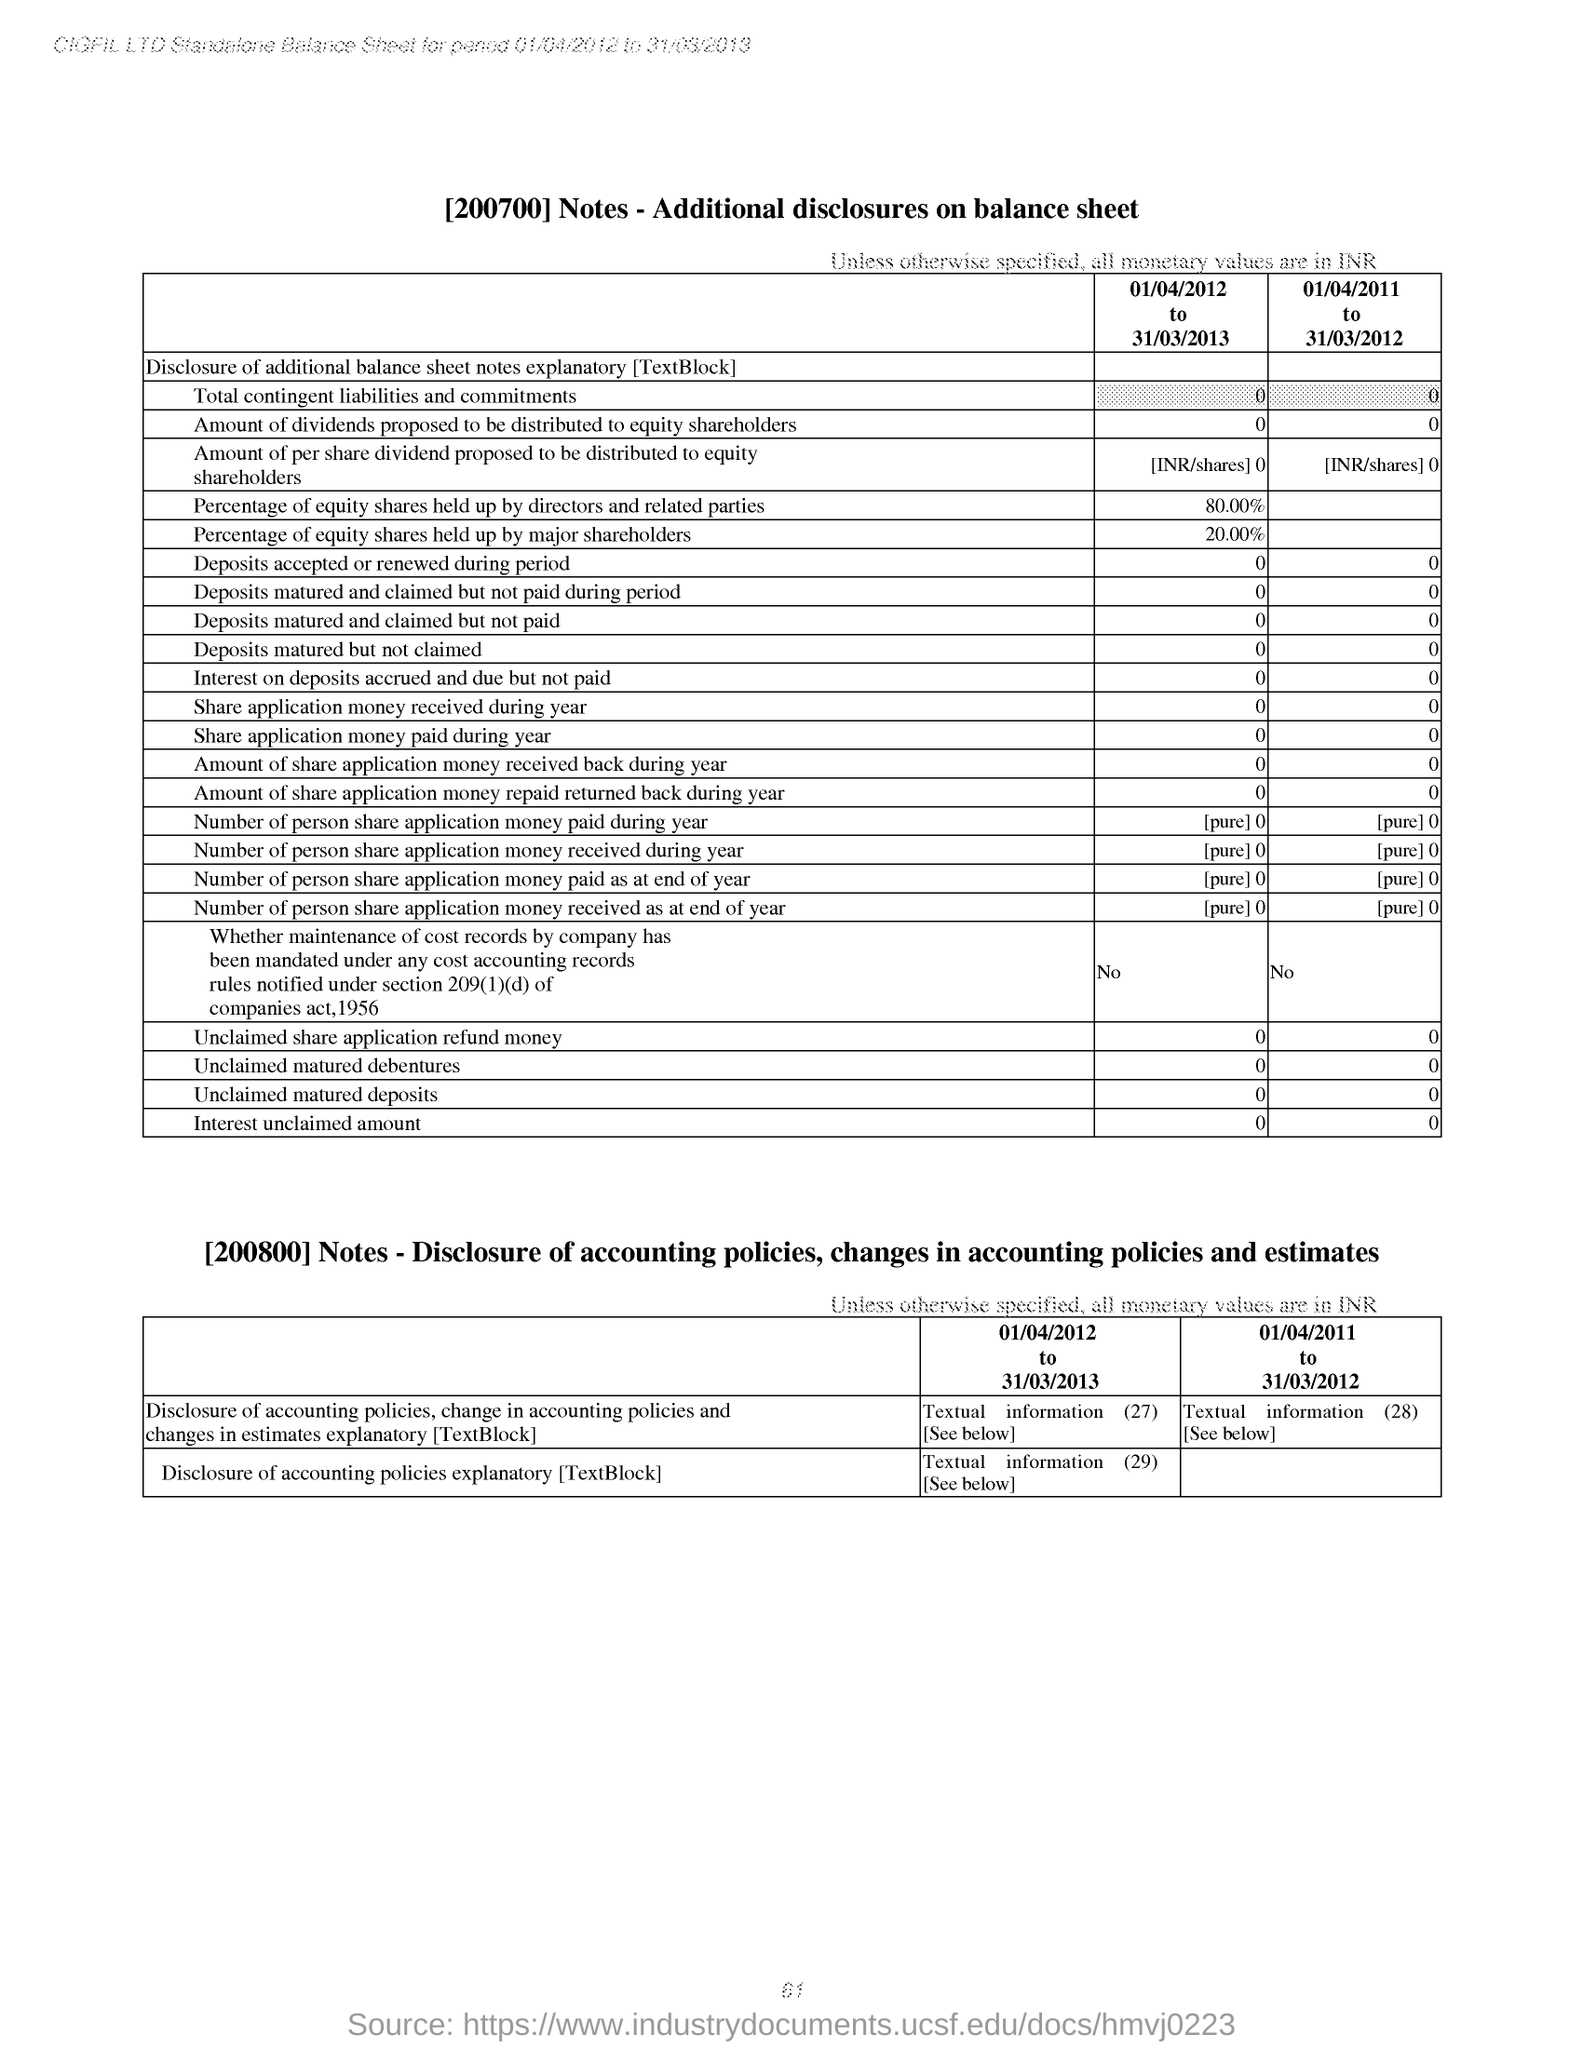Are there any instances of share application money due in this period? According to the displayed balance sheet information, there has been no share application money due at any point during the years from April 1, 2011, to March 31, 2013. This suggests that the company didn't have pending payments to collect from shareholders for allotted shares during this timeframe. 